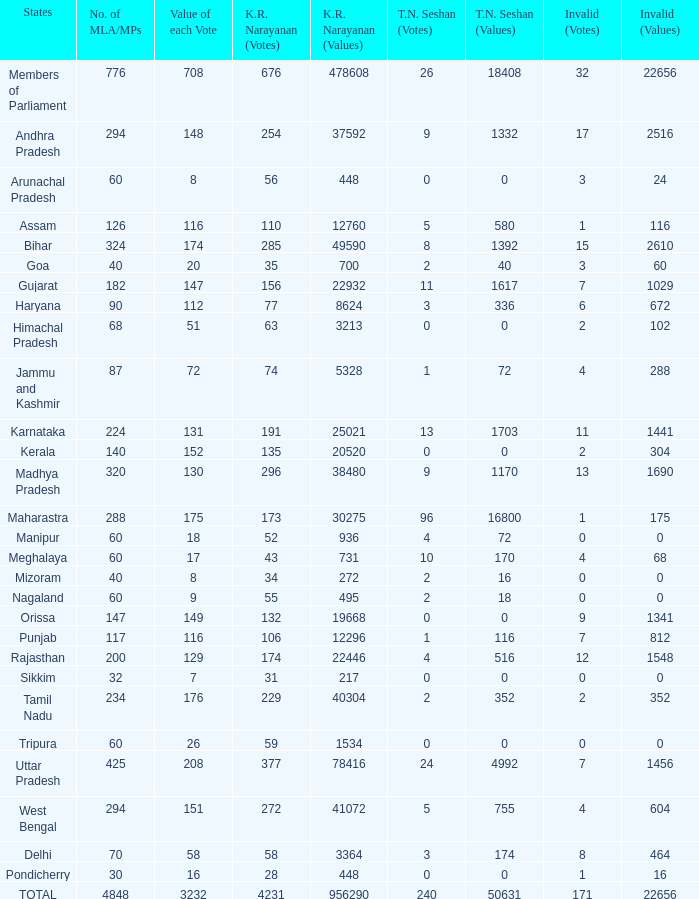Identify the k. r. narayanan principles for pondicherry. 448.0. 